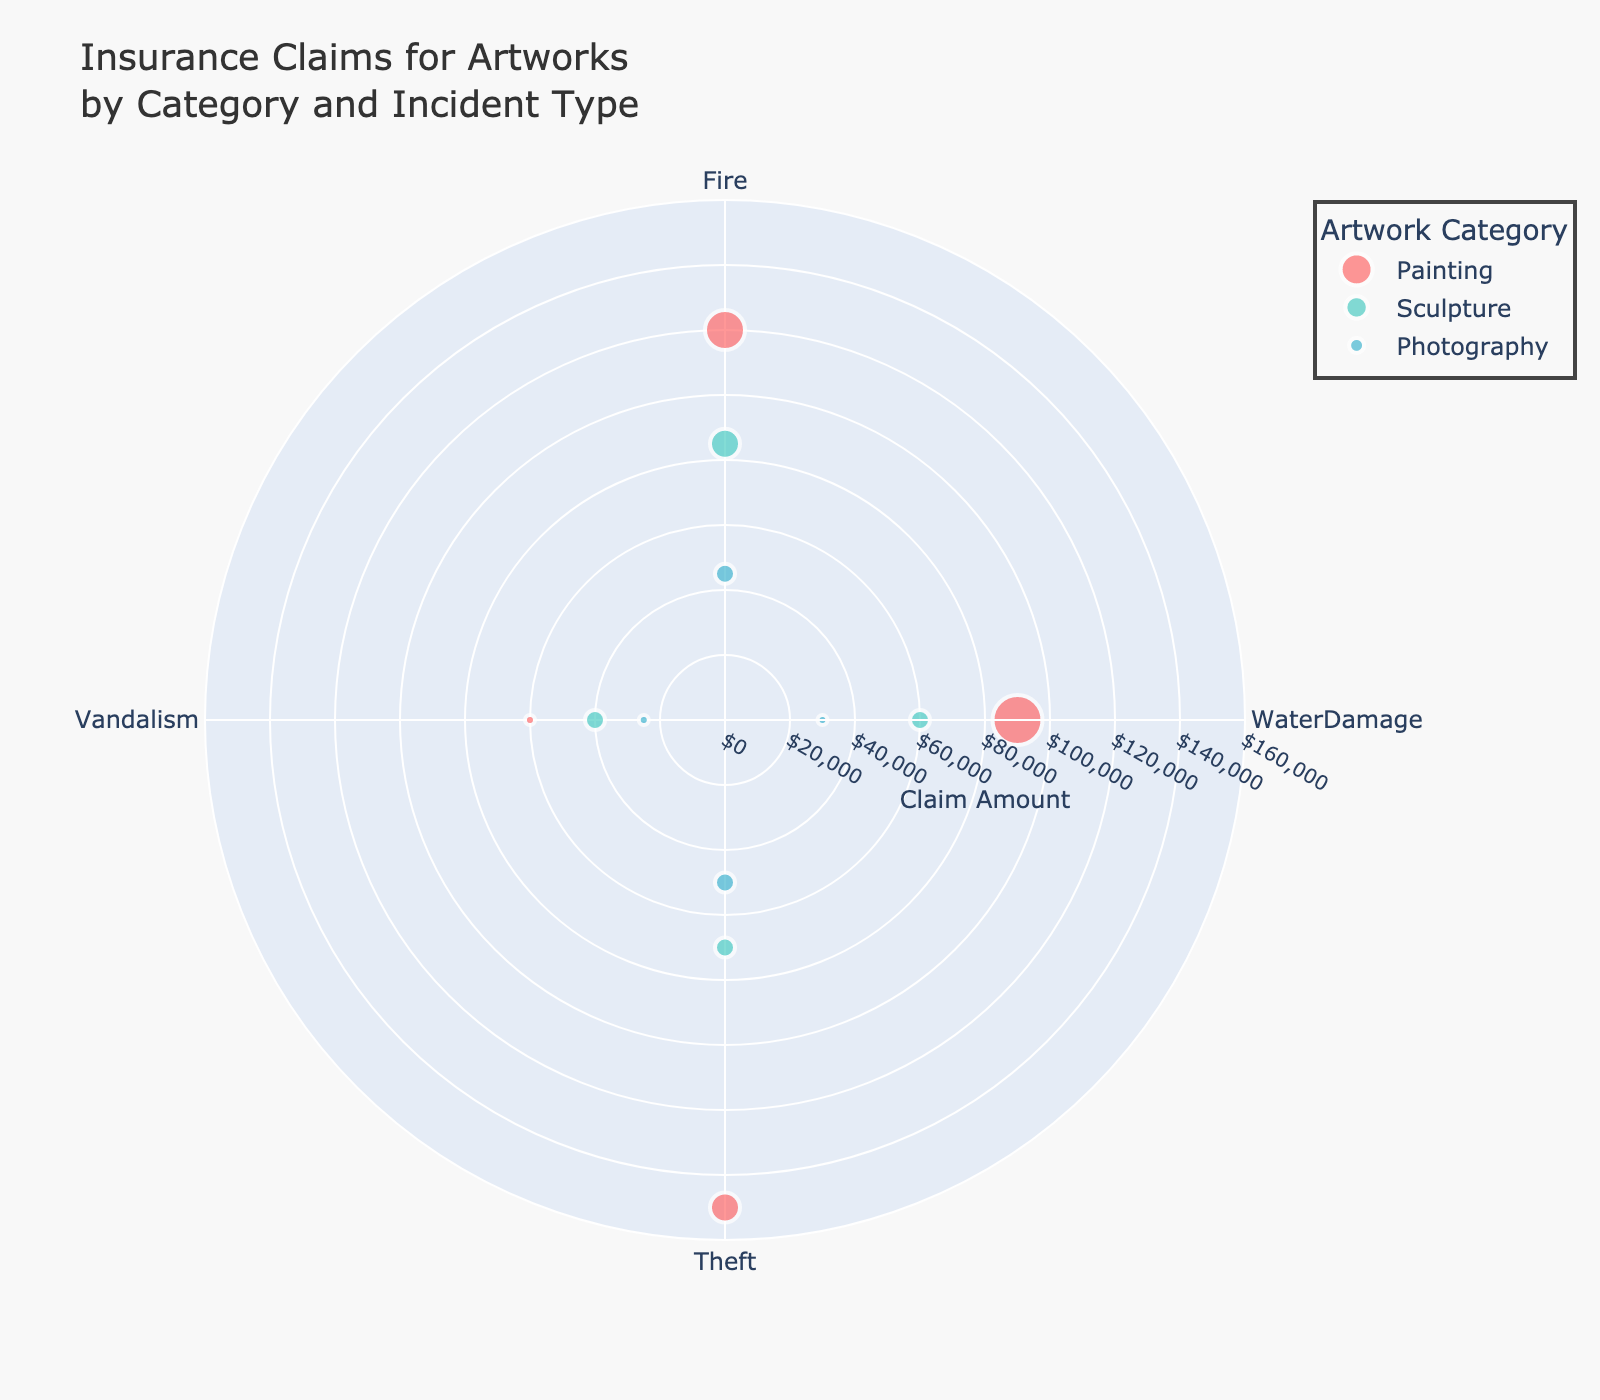What is the title of the figure? The title of the figure is prominently displayed at the top of the chart.
Answer: Insurance Claims for Artworks by Category and Incident Type Which artwork category has the highest claim amount for Theft incidents? Look for the largest radial value (distance from the center) under "Theft" and identify the corresponding artwork category.
Answer: Painting How many incident types are shown in the figure? Count the unique labels on the angular axis (the circle representing different types of incidents).
Answer: 4 What is the total incident count for Painting across all incidents? Sum the incident counts for all incidents within the Painting category.
Answer: 13 Which incident type has the highest claim amount? Identify the data point farthest from the center among all incident types and note its incident type.
Answer: Theft How does the claim amount for Sculpture in Vandalism compare to Painting in Vandalism? Compare the radial distances of the Vandalism markers for Sculpture and Painting.
Answer: Painting has a higher claim amount than Sculpture What is the size of the marker representing Water Damage incidents for Photography? Observe the marker size for Photography under the Water Damage incident type and multiply it by the constant factor given (5).
Answer: 5 Among the categories of Painting, Sculpture, and Photography, which has the smallest claim amount for Fire incidents? Look for the shortest radial distance for Fire incidents across the three categories.
Answer: Photography How does the number of Water Damage incidents compare between Painting and Sculpture? Look at the marker sizes for Water Damage incidents in both categories and compare.
Answer: Painting has more incidents than Sculpture What is the radial range used for the claim amount axis in this chart? Identify the minimum and maximum values indicated on the radial axis.
Answer: 0 to 160,000 